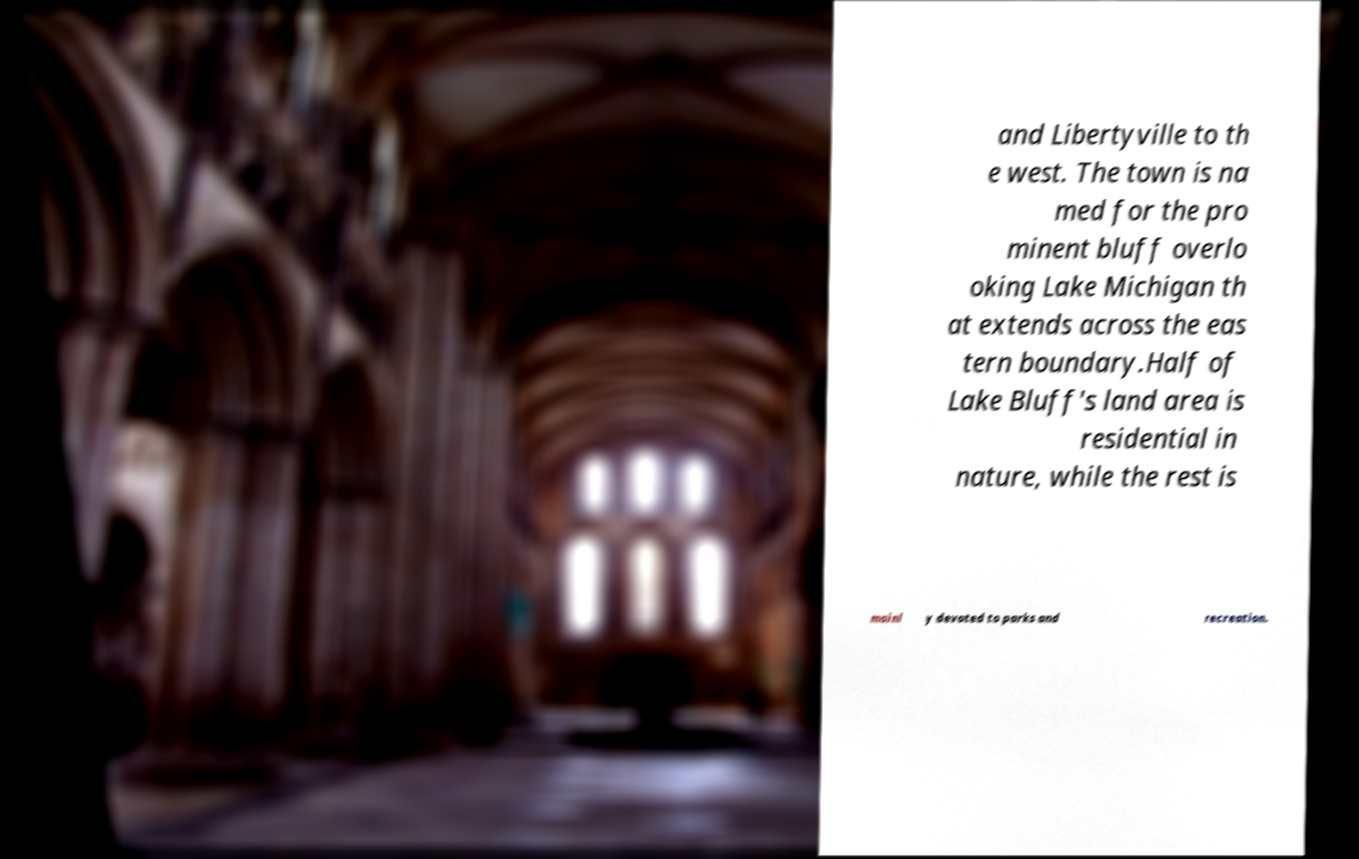For documentation purposes, I need the text within this image transcribed. Could you provide that? and Libertyville to th e west. The town is na med for the pro minent bluff overlo oking Lake Michigan th at extends across the eas tern boundary.Half of Lake Bluff's land area is residential in nature, while the rest is mainl y devoted to parks and recreation. 